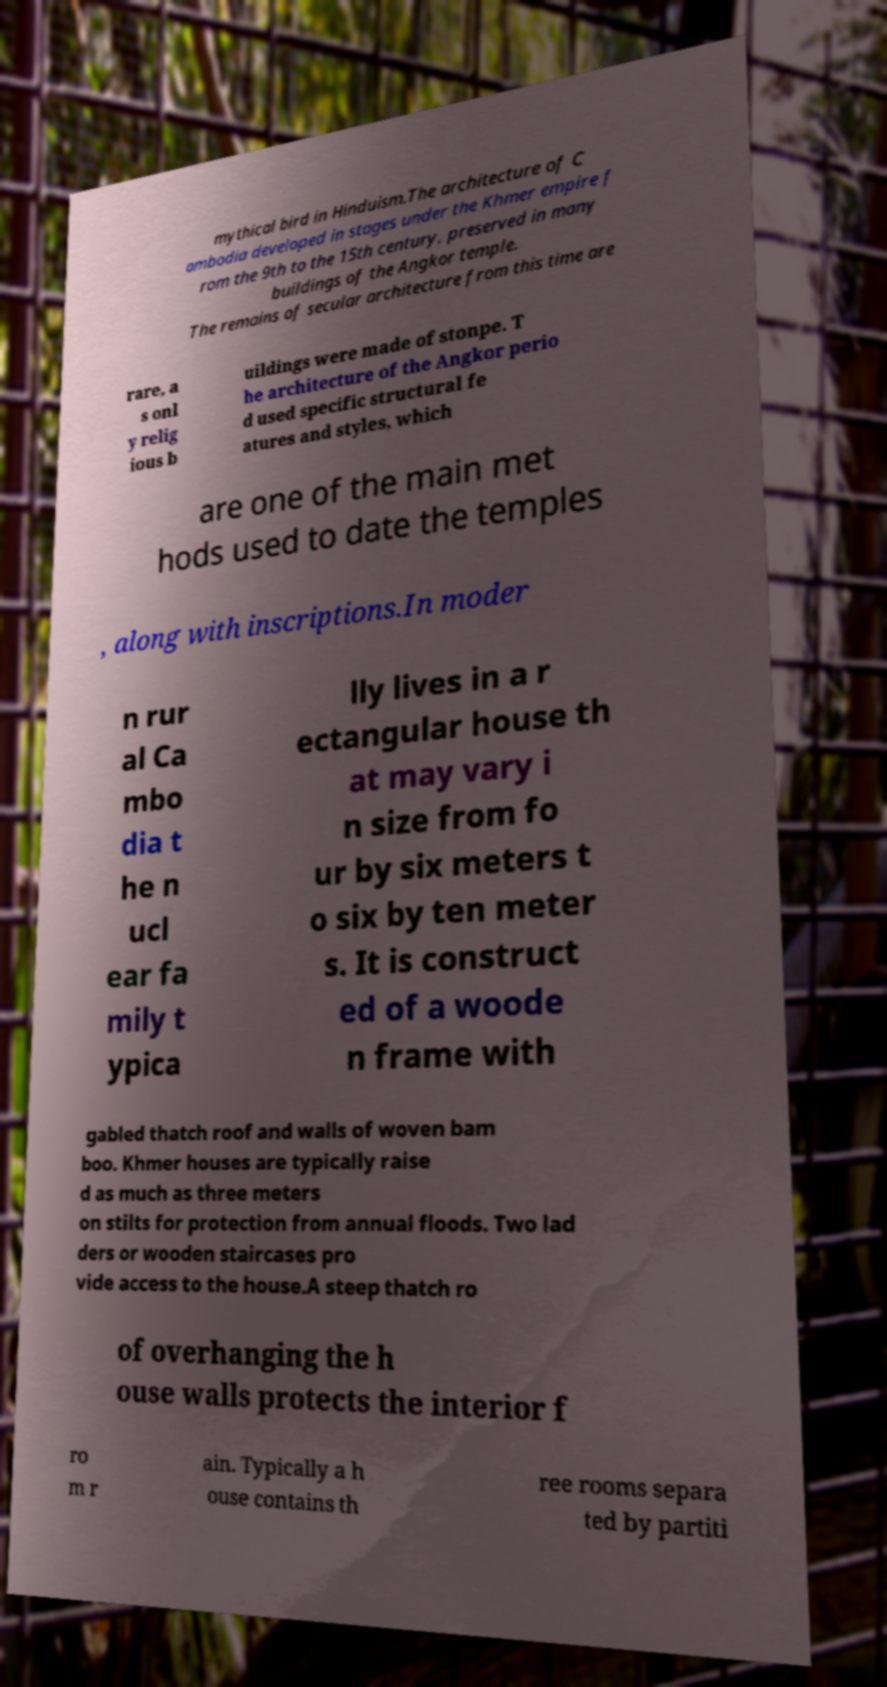Can you read and provide the text displayed in the image?This photo seems to have some interesting text. Can you extract and type it out for me? mythical bird in Hinduism.The architecture of C ambodia developed in stages under the Khmer empire f rom the 9th to the 15th century, preserved in many buildings of the Angkor temple. The remains of secular architecture from this time are rare, a s onl y relig ious b uildings were made of stonpe. T he architecture of the Angkor perio d used specific structural fe atures and styles, which are one of the main met hods used to date the temples , along with inscriptions.In moder n rur al Ca mbo dia t he n ucl ear fa mily t ypica lly lives in a r ectangular house th at may vary i n size from fo ur by six meters t o six by ten meter s. It is construct ed of a woode n frame with gabled thatch roof and walls of woven bam boo. Khmer houses are typically raise d as much as three meters on stilts for protection from annual floods. Two lad ders or wooden staircases pro vide access to the house.A steep thatch ro of overhanging the h ouse walls protects the interior f ro m r ain. Typically a h ouse contains th ree rooms separa ted by partiti 